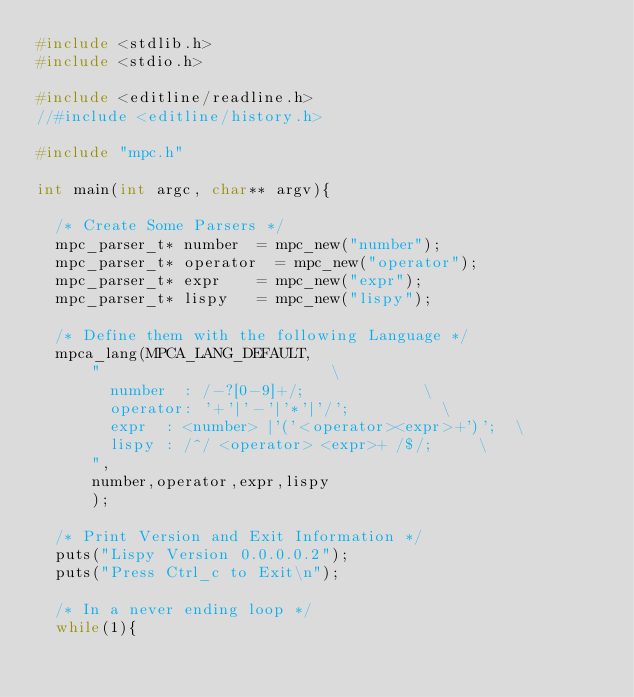<code> <loc_0><loc_0><loc_500><loc_500><_C_>#include <stdlib.h>
#include <stdio.h>

#include <editline/readline.h>
//#include <editline/history.h>

#include "mpc.h"

int main(int argc, char** argv){

	/* Create Some Parsers */
	mpc_parser_t* number 	= mpc_new("number");
	mpc_parser_t* operator 	= mpc_new("operator");
	mpc_parser_t* expr		= mpc_new("expr");
	mpc_parser_t* lispy		= mpc_new("lispy");

	/* Define them with the following Language */
	mpca_lang(MPCA_LANG_DEFAULT,
			"													\
				number	:	/-?[0-9]+/;							\
				operator:	'+'|'-'|'*'|'/';					\
				expr	:	<number> |'('<operator><expr>+')';	\
				lispy	:	/^/ <operator> <expr>+ /$/;			\
			",
			number,operator,expr,lispy
			);

	/* Print Version and Exit Information */
	puts("Lispy Version 0.0.0.0.2");
	puts("Press Ctrl_c to Exit\n");
	
	/* In a never ending loop */
	while(1){
</code> 